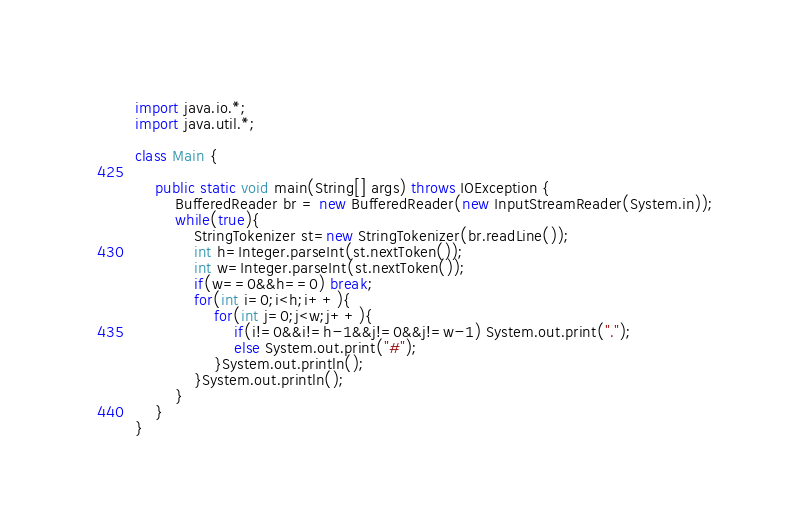<code> <loc_0><loc_0><loc_500><loc_500><_Java_>import java.io.*;
import java.util.*;

class Main {

    public static void main(String[] args) throws IOException {
        BufferedReader br = new BufferedReader(new InputStreamReader(System.in));
        while(true){
            StringTokenizer st=new StringTokenizer(br.readLine());
            int h=Integer.parseInt(st.nextToken());
            int w=Integer.parseInt(st.nextToken());
            if(w==0&&h==0) break;
            for(int i=0;i<h;i++){
                for(int j=0;j<w;j++){
                    if(i!=0&&i!=h-1&&j!=0&&j!=w-1) System.out.print(".");
                    else System.out.print("#");
                }System.out.println();
            }System.out.println();
        }
    }
}</code> 